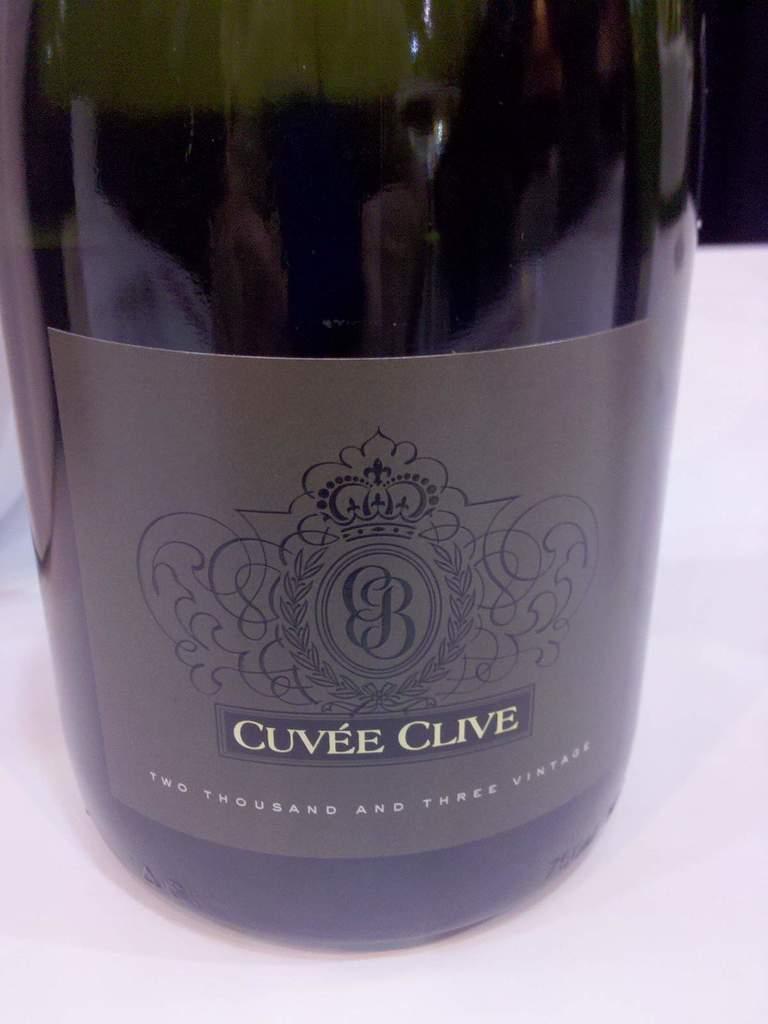Can you describe this image briefly? In this picture we can see a bottle with sticker on a white object. In the background of the image it is dark. 